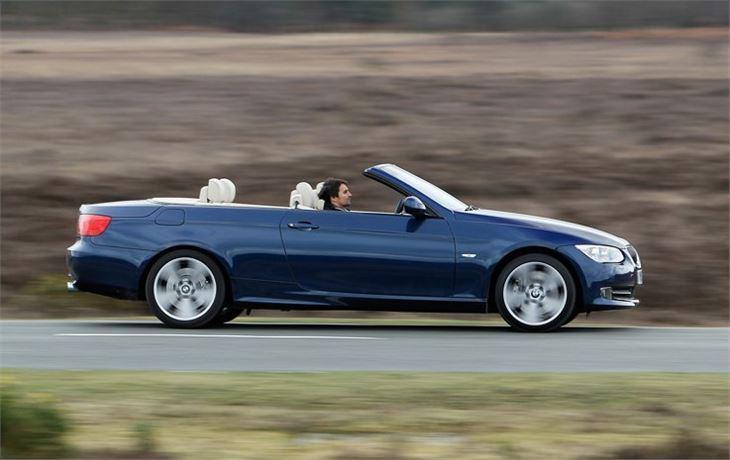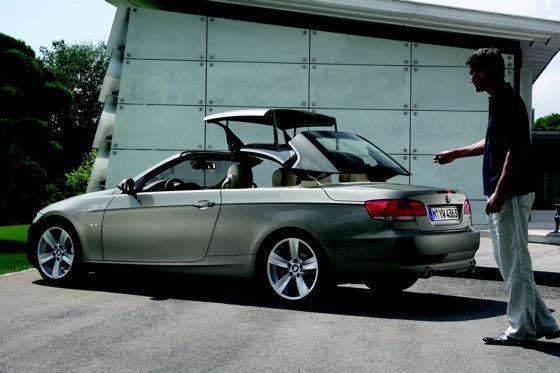The first image is the image on the left, the second image is the image on the right. For the images shown, is this caption "Two convertible sports cars are parked so that their license plates are visible, one blue with white seat headrests and one silver metallic." true? Answer yes or no. No. The first image is the image on the left, the second image is the image on the right. Analyze the images presented: Is the assertion "An image shows a parked deep blue convertible with noone inside it." valid? Answer yes or no. No. 